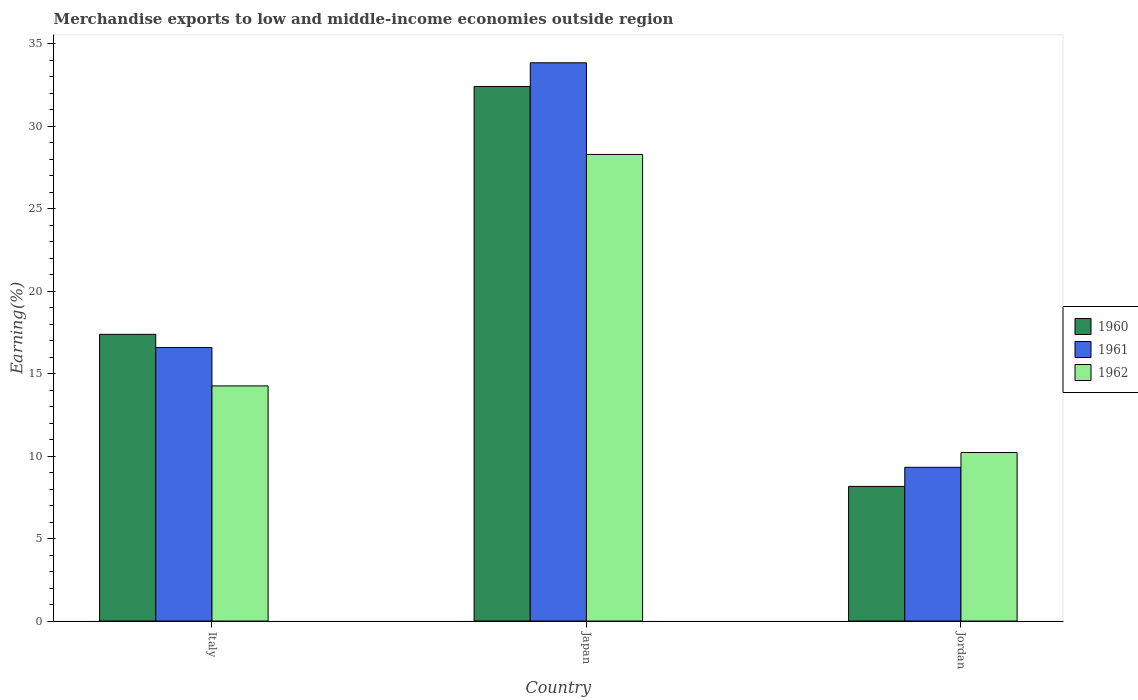Are the number of bars on each tick of the X-axis equal?
Provide a short and direct response. Yes. In how many cases, is the number of bars for a given country not equal to the number of legend labels?
Your response must be concise. 0. What is the percentage of amount earned from merchandise exports in 1961 in Italy?
Your answer should be very brief. 16.58. Across all countries, what is the maximum percentage of amount earned from merchandise exports in 1962?
Provide a short and direct response. 28.29. Across all countries, what is the minimum percentage of amount earned from merchandise exports in 1962?
Your answer should be very brief. 10.22. In which country was the percentage of amount earned from merchandise exports in 1961 maximum?
Ensure brevity in your answer.  Japan. In which country was the percentage of amount earned from merchandise exports in 1961 minimum?
Provide a short and direct response. Jordan. What is the total percentage of amount earned from merchandise exports in 1961 in the graph?
Your answer should be very brief. 59.76. What is the difference between the percentage of amount earned from merchandise exports in 1962 in Italy and that in Japan?
Offer a very short reply. -14.04. What is the difference between the percentage of amount earned from merchandise exports in 1960 in Jordan and the percentage of amount earned from merchandise exports in 1962 in Italy?
Your answer should be very brief. -6.09. What is the average percentage of amount earned from merchandise exports in 1961 per country?
Keep it short and to the point. 19.92. What is the difference between the percentage of amount earned from merchandise exports of/in 1960 and percentage of amount earned from merchandise exports of/in 1962 in Jordan?
Provide a short and direct response. -2.06. In how many countries, is the percentage of amount earned from merchandise exports in 1961 greater than 16 %?
Your response must be concise. 2. What is the ratio of the percentage of amount earned from merchandise exports in 1962 in Italy to that in Japan?
Provide a short and direct response. 0.5. Is the difference between the percentage of amount earned from merchandise exports in 1960 in Italy and Japan greater than the difference between the percentage of amount earned from merchandise exports in 1962 in Italy and Japan?
Keep it short and to the point. No. What is the difference between the highest and the second highest percentage of amount earned from merchandise exports in 1962?
Keep it short and to the point. -18.07. What is the difference between the highest and the lowest percentage of amount earned from merchandise exports in 1961?
Offer a terse response. 24.53. What does the 2nd bar from the left in Italy represents?
Make the answer very short. 1961. What does the 3rd bar from the right in Italy represents?
Your answer should be compact. 1960. Is it the case that in every country, the sum of the percentage of amount earned from merchandise exports in 1962 and percentage of amount earned from merchandise exports in 1961 is greater than the percentage of amount earned from merchandise exports in 1960?
Provide a succinct answer. Yes. Are all the bars in the graph horizontal?
Ensure brevity in your answer.  No. Does the graph contain any zero values?
Keep it short and to the point. No. Where does the legend appear in the graph?
Ensure brevity in your answer.  Center right. How are the legend labels stacked?
Keep it short and to the point. Vertical. What is the title of the graph?
Give a very brief answer. Merchandise exports to low and middle-income economies outside region. What is the label or title of the X-axis?
Give a very brief answer. Country. What is the label or title of the Y-axis?
Offer a terse response. Earning(%). What is the Earning(%) in 1960 in Italy?
Ensure brevity in your answer.  17.38. What is the Earning(%) in 1961 in Italy?
Keep it short and to the point. 16.58. What is the Earning(%) in 1962 in Italy?
Offer a terse response. 14.26. What is the Earning(%) in 1960 in Japan?
Give a very brief answer. 32.41. What is the Earning(%) in 1961 in Japan?
Offer a terse response. 33.85. What is the Earning(%) in 1962 in Japan?
Give a very brief answer. 28.29. What is the Earning(%) in 1960 in Jordan?
Your answer should be very brief. 8.16. What is the Earning(%) in 1961 in Jordan?
Your answer should be compact. 9.32. What is the Earning(%) of 1962 in Jordan?
Offer a terse response. 10.22. Across all countries, what is the maximum Earning(%) of 1960?
Make the answer very short. 32.41. Across all countries, what is the maximum Earning(%) of 1961?
Keep it short and to the point. 33.85. Across all countries, what is the maximum Earning(%) of 1962?
Make the answer very short. 28.29. Across all countries, what is the minimum Earning(%) of 1960?
Your answer should be compact. 8.16. Across all countries, what is the minimum Earning(%) of 1961?
Ensure brevity in your answer.  9.32. Across all countries, what is the minimum Earning(%) in 1962?
Offer a very short reply. 10.22. What is the total Earning(%) in 1960 in the graph?
Make the answer very short. 57.96. What is the total Earning(%) of 1961 in the graph?
Your answer should be compact. 59.76. What is the total Earning(%) in 1962 in the graph?
Keep it short and to the point. 52.77. What is the difference between the Earning(%) in 1960 in Italy and that in Japan?
Your answer should be compact. -15.03. What is the difference between the Earning(%) of 1961 in Italy and that in Japan?
Offer a terse response. -17.27. What is the difference between the Earning(%) in 1962 in Italy and that in Japan?
Ensure brevity in your answer.  -14.04. What is the difference between the Earning(%) in 1960 in Italy and that in Jordan?
Provide a short and direct response. 9.22. What is the difference between the Earning(%) in 1961 in Italy and that in Jordan?
Offer a very short reply. 7.26. What is the difference between the Earning(%) of 1962 in Italy and that in Jordan?
Make the answer very short. 4.04. What is the difference between the Earning(%) in 1960 in Japan and that in Jordan?
Your answer should be compact. 24.25. What is the difference between the Earning(%) in 1961 in Japan and that in Jordan?
Offer a terse response. 24.53. What is the difference between the Earning(%) in 1962 in Japan and that in Jordan?
Provide a short and direct response. 18.07. What is the difference between the Earning(%) in 1960 in Italy and the Earning(%) in 1961 in Japan?
Give a very brief answer. -16.47. What is the difference between the Earning(%) in 1960 in Italy and the Earning(%) in 1962 in Japan?
Your answer should be very brief. -10.91. What is the difference between the Earning(%) of 1961 in Italy and the Earning(%) of 1962 in Japan?
Provide a short and direct response. -11.71. What is the difference between the Earning(%) of 1960 in Italy and the Earning(%) of 1961 in Jordan?
Offer a very short reply. 8.06. What is the difference between the Earning(%) of 1960 in Italy and the Earning(%) of 1962 in Jordan?
Give a very brief answer. 7.17. What is the difference between the Earning(%) of 1961 in Italy and the Earning(%) of 1962 in Jordan?
Your answer should be compact. 6.36. What is the difference between the Earning(%) of 1960 in Japan and the Earning(%) of 1961 in Jordan?
Provide a succinct answer. 23.09. What is the difference between the Earning(%) of 1960 in Japan and the Earning(%) of 1962 in Jordan?
Give a very brief answer. 22.2. What is the difference between the Earning(%) of 1961 in Japan and the Earning(%) of 1962 in Jordan?
Offer a very short reply. 23.63. What is the average Earning(%) of 1960 per country?
Your answer should be very brief. 19.32. What is the average Earning(%) in 1961 per country?
Give a very brief answer. 19.92. What is the average Earning(%) of 1962 per country?
Your response must be concise. 17.59. What is the difference between the Earning(%) of 1960 and Earning(%) of 1961 in Italy?
Provide a succinct answer. 0.8. What is the difference between the Earning(%) in 1960 and Earning(%) in 1962 in Italy?
Your answer should be very brief. 3.13. What is the difference between the Earning(%) of 1961 and Earning(%) of 1962 in Italy?
Provide a succinct answer. 2.33. What is the difference between the Earning(%) in 1960 and Earning(%) in 1961 in Japan?
Your answer should be compact. -1.44. What is the difference between the Earning(%) of 1960 and Earning(%) of 1962 in Japan?
Your response must be concise. 4.12. What is the difference between the Earning(%) of 1961 and Earning(%) of 1962 in Japan?
Offer a terse response. 5.56. What is the difference between the Earning(%) in 1960 and Earning(%) in 1961 in Jordan?
Provide a succinct answer. -1.16. What is the difference between the Earning(%) of 1960 and Earning(%) of 1962 in Jordan?
Give a very brief answer. -2.06. What is the difference between the Earning(%) of 1961 and Earning(%) of 1962 in Jordan?
Keep it short and to the point. -0.9. What is the ratio of the Earning(%) of 1960 in Italy to that in Japan?
Make the answer very short. 0.54. What is the ratio of the Earning(%) of 1961 in Italy to that in Japan?
Your answer should be very brief. 0.49. What is the ratio of the Earning(%) of 1962 in Italy to that in Japan?
Offer a very short reply. 0.5. What is the ratio of the Earning(%) of 1960 in Italy to that in Jordan?
Provide a short and direct response. 2.13. What is the ratio of the Earning(%) in 1961 in Italy to that in Jordan?
Give a very brief answer. 1.78. What is the ratio of the Earning(%) in 1962 in Italy to that in Jordan?
Offer a terse response. 1.4. What is the ratio of the Earning(%) of 1960 in Japan to that in Jordan?
Provide a succinct answer. 3.97. What is the ratio of the Earning(%) of 1961 in Japan to that in Jordan?
Your answer should be very brief. 3.63. What is the ratio of the Earning(%) in 1962 in Japan to that in Jordan?
Offer a terse response. 2.77. What is the difference between the highest and the second highest Earning(%) of 1960?
Your answer should be compact. 15.03. What is the difference between the highest and the second highest Earning(%) of 1961?
Your response must be concise. 17.27. What is the difference between the highest and the second highest Earning(%) in 1962?
Ensure brevity in your answer.  14.04. What is the difference between the highest and the lowest Earning(%) of 1960?
Make the answer very short. 24.25. What is the difference between the highest and the lowest Earning(%) of 1961?
Your answer should be very brief. 24.53. What is the difference between the highest and the lowest Earning(%) of 1962?
Your answer should be compact. 18.07. 